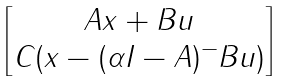<formula> <loc_0><loc_0><loc_500><loc_500>\begin{bmatrix} A x + B u \\ C ( x - ( \alpha I - A ) ^ { - } B u ) \end{bmatrix}</formula> 